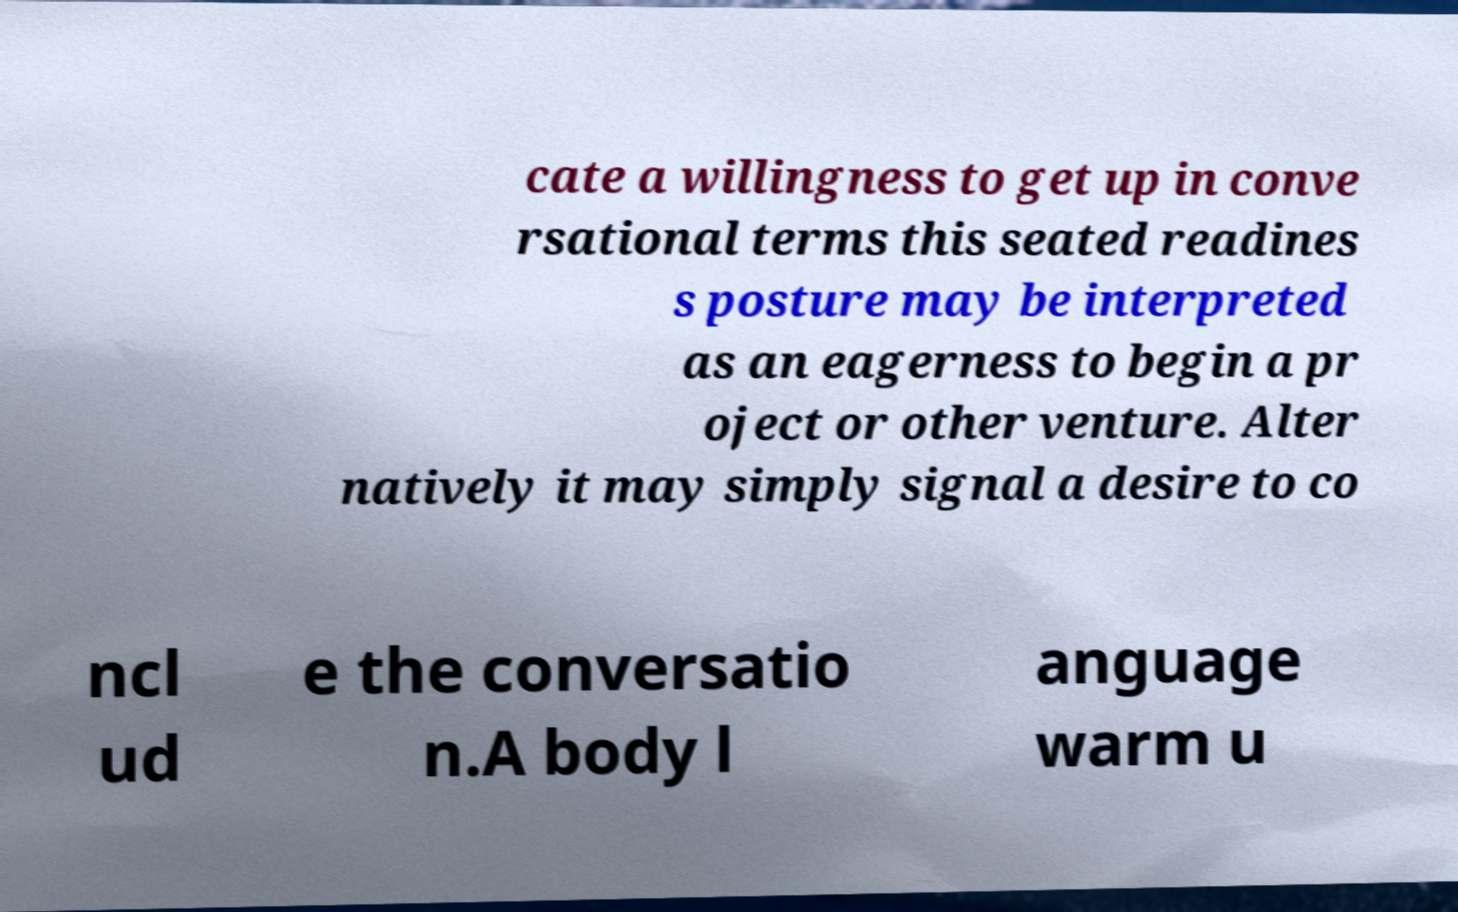Can you accurately transcribe the text from the provided image for me? cate a willingness to get up in conve rsational terms this seated readines s posture may be interpreted as an eagerness to begin a pr oject or other venture. Alter natively it may simply signal a desire to co ncl ud e the conversatio n.A body l anguage warm u 